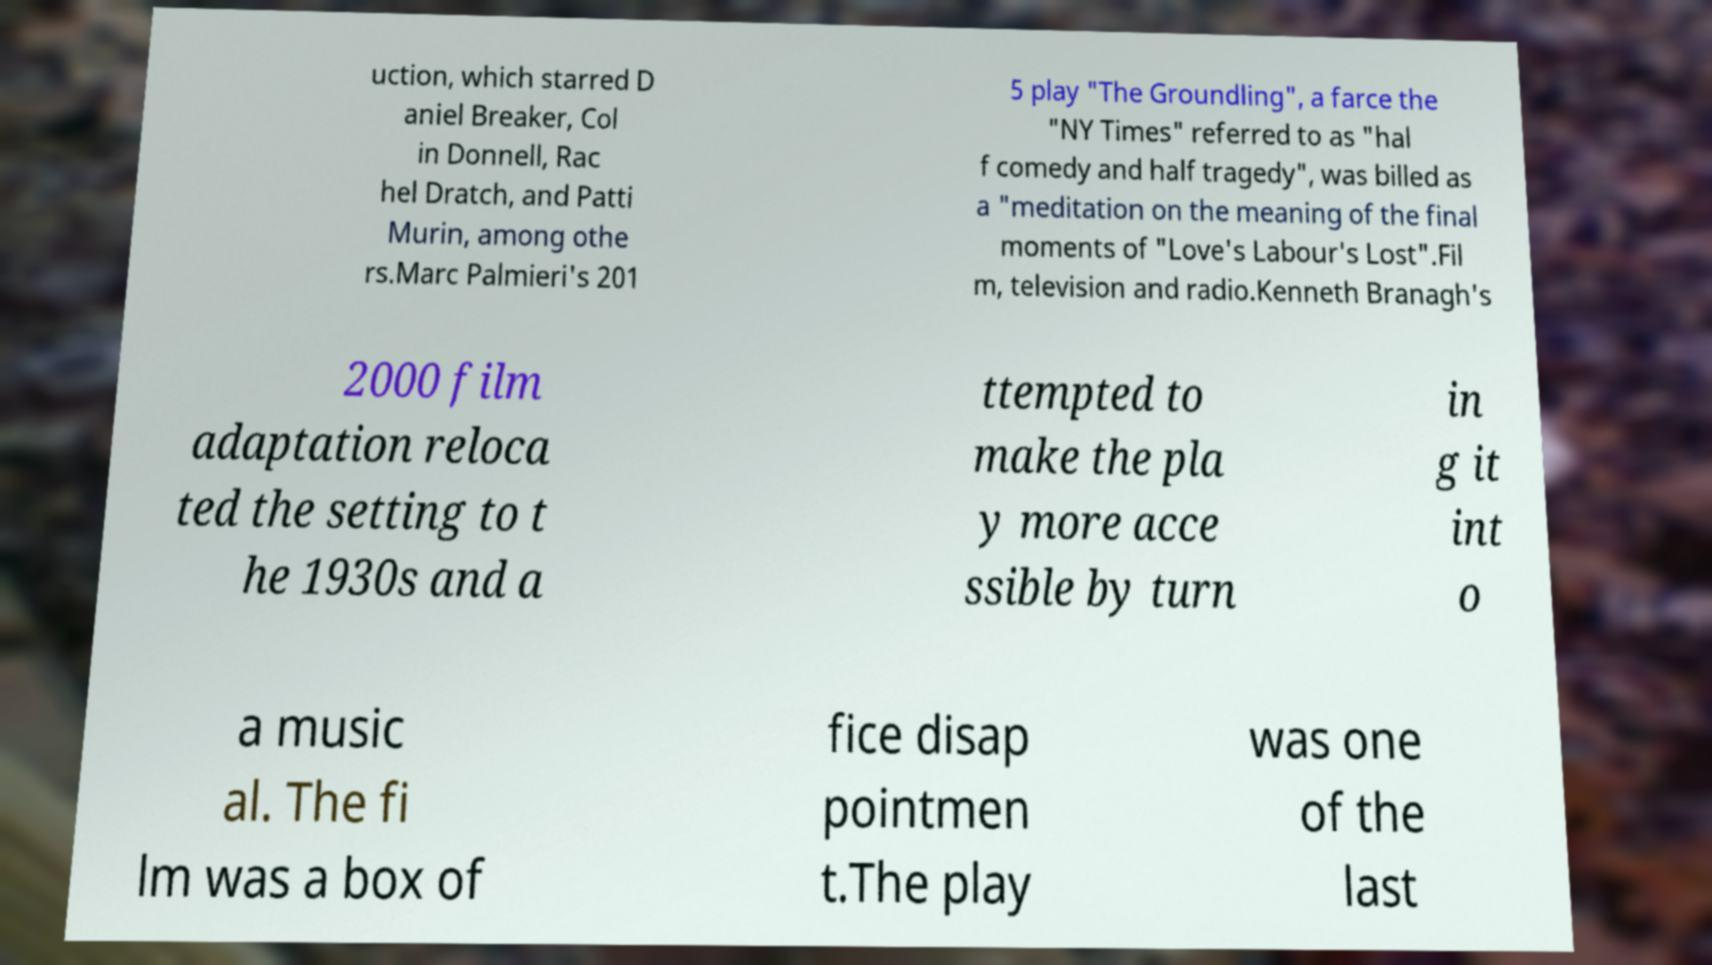I need the written content from this picture converted into text. Can you do that? uction, which starred D aniel Breaker, Col in Donnell, Rac hel Dratch, and Patti Murin, among othe rs.Marc Palmieri's 201 5 play "The Groundling", a farce the "NY Times" referred to as "hal f comedy and half tragedy", was billed as a "meditation on the meaning of the final moments of "Love's Labour's Lost".Fil m, television and radio.Kenneth Branagh's 2000 film adaptation reloca ted the setting to t he 1930s and a ttempted to make the pla y more acce ssible by turn in g it int o a music al. The fi lm was a box of fice disap pointmen t.The play was one of the last 